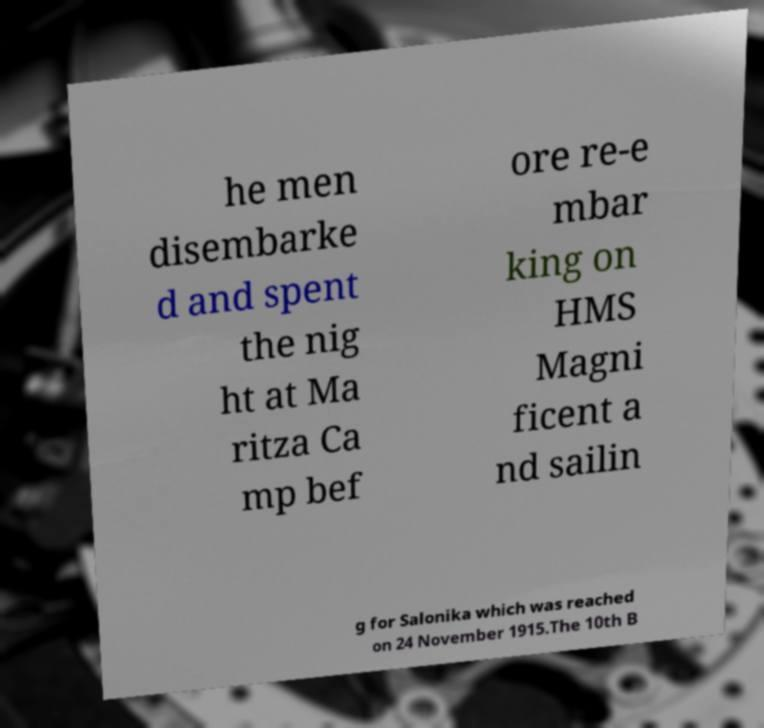Can you read and provide the text displayed in the image?This photo seems to have some interesting text. Can you extract and type it out for me? he men disembarke d and spent the nig ht at Ma ritza Ca mp bef ore re-e mbar king on HMS Magni ficent a nd sailin g for Salonika which was reached on 24 November 1915.The 10th B 